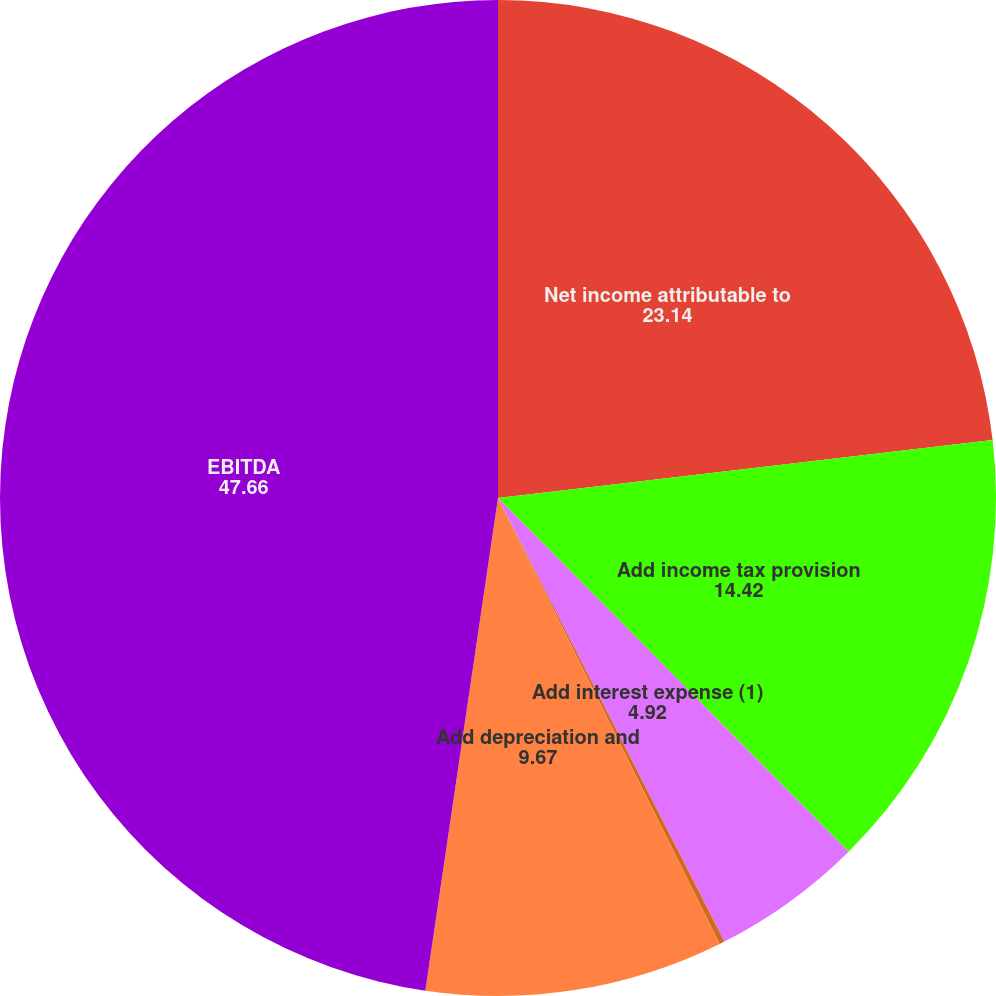Convert chart. <chart><loc_0><loc_0><loc_500><loc_500><pie_chart><fcel>Net income attributable to<fcel>Add income tax provision<fcel>Add interest expense (1)<fcel>Subtract interest income<fcel>Add depreciation and<fcel>EBITDA<nl><fcel>23.14%<fcel>14.42%<fcel>4.92%<fcel>0.17%<fcel>9.67%<fcel>47.66%<nl></chart> 